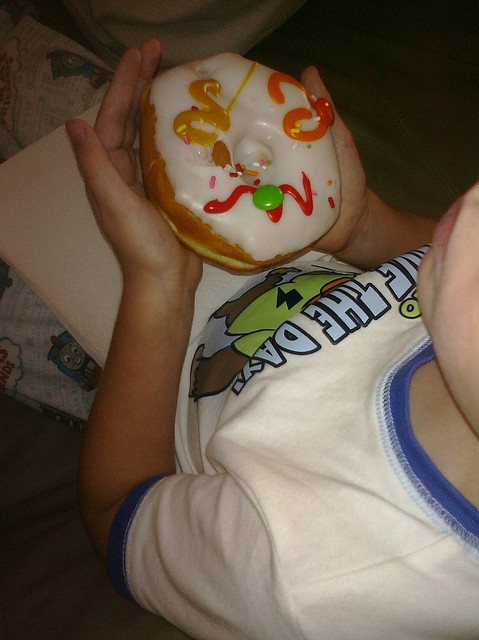Describe the objects in this image and their specific colors. I can see people in black, maroon, gray, and darkgray tones and donut in black, darkgray, gray, and maroon tones in this image. 